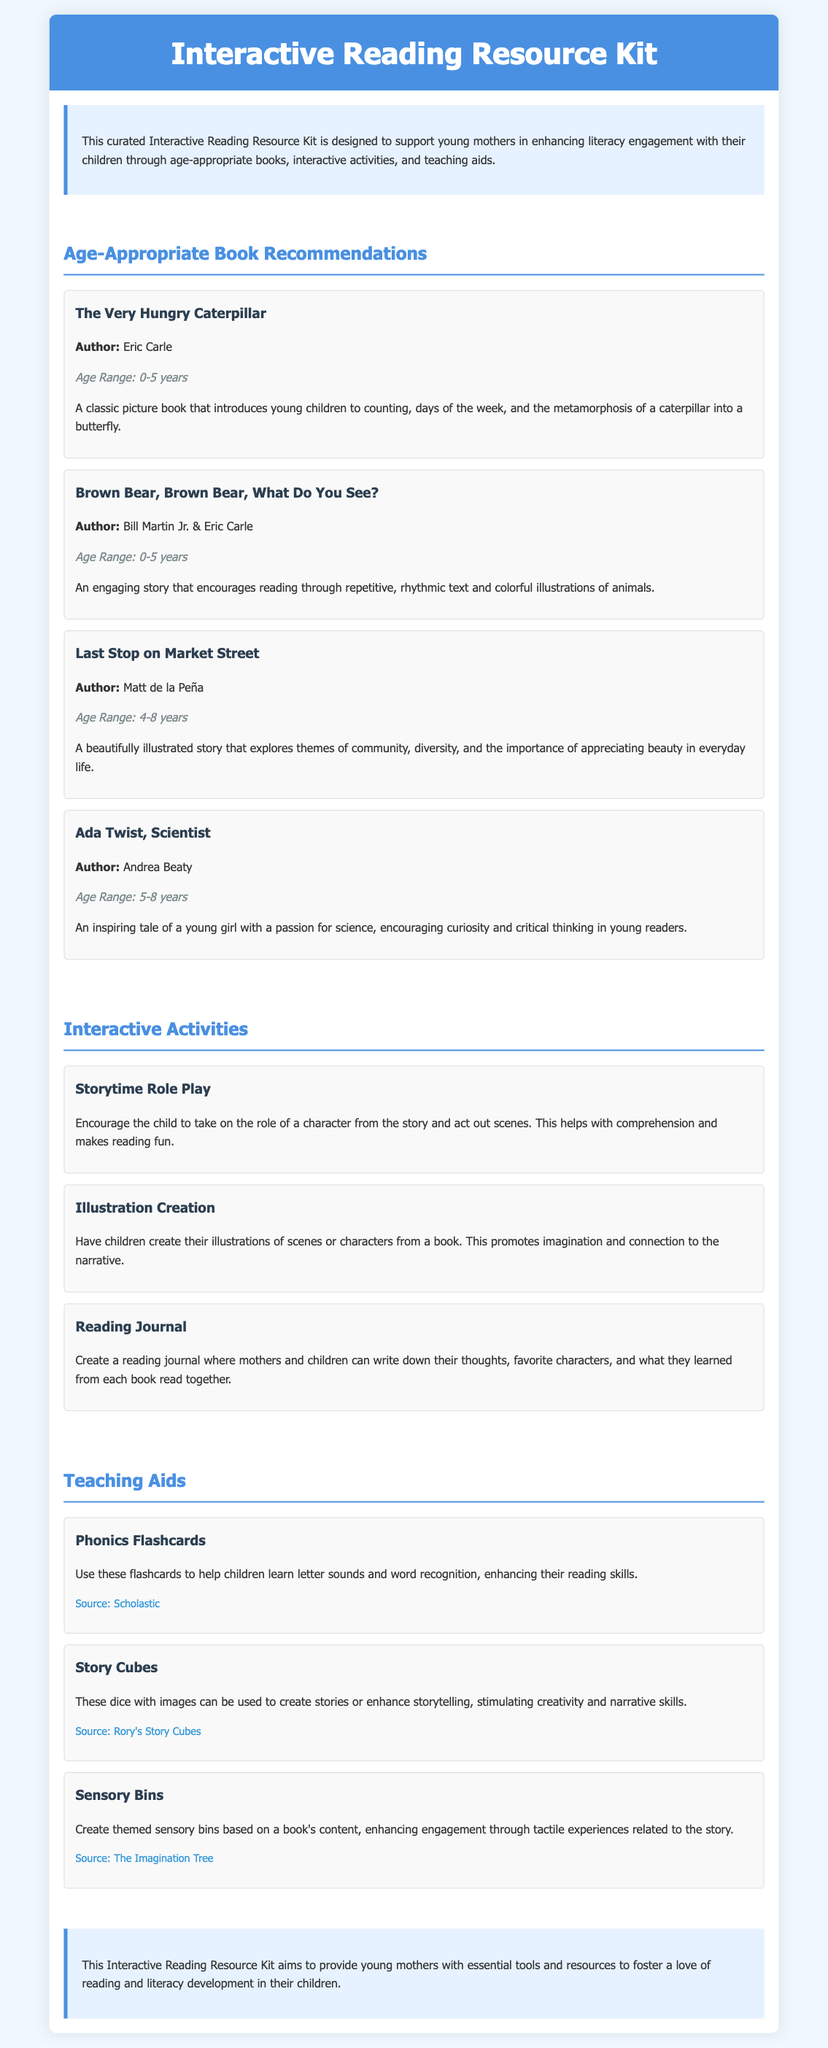What is the title of the resource kit? The title is presented in the header of the document, which is "Interactive Reading Resource Kit."
Answer: Interactive Reading Resource Kit Who is the intended audience for the resource kit? The document specifies that the resource kit is designed for young mothers and their children.
Answer: Young mothers and their children What age range is "The Very Hungry Caterpillar" suitable for? The age range is mentioned directly under the book title, indicating it is suitable for children aged 0-5 years.
Answer: 0-5 years How many interactive activities are listed in the document? The section on interactive activities includes three distinct activities.
Answer: Three What is one recommended activity to enhance reading engagement? The document describes several activities, one of which is "Storytime Role Play."
Answer: Storytime Role Play Which author wrote "Last Stop on Market Street"? The author’s name is given directly under the book title in the document, which is Matt de la Peña.
Answer: Matt de la Peña What type of resource is "Phonics Flashcards"? The document categorizes this resource as a "Teaching Aid."
Answer: Teaching Aid What does the reading journal activity promote? The explanation indicates that the reading journal encourages mothers and children to write down their thoughts and reflections, enhancing engagement.
Answer: Engagement through reflection What resource is provided for creative storytelling? The document includes "Story Cubes" as a resource that stimulates creativity and storytelling skills.
Answer: Story Cubes 